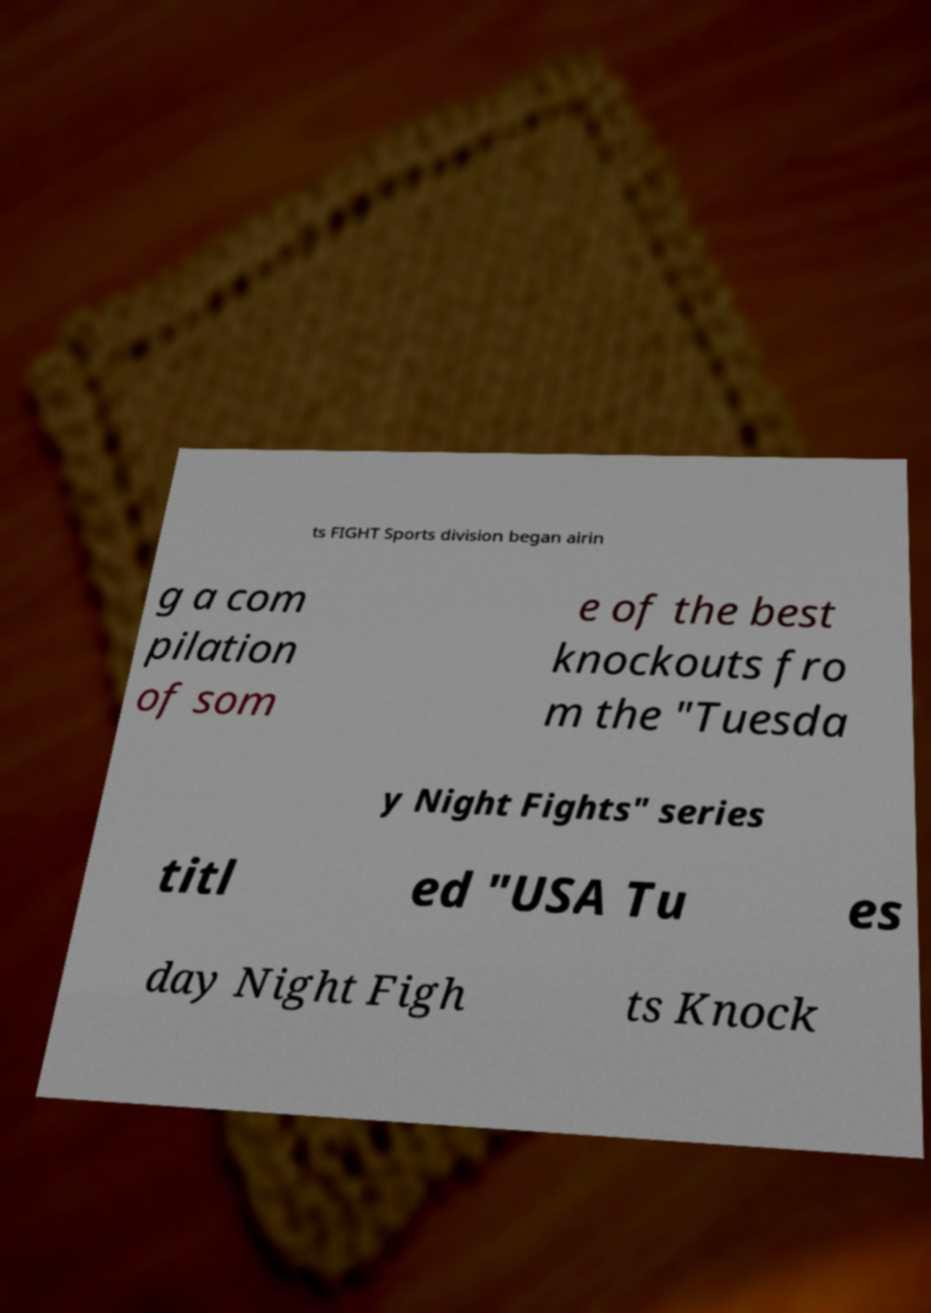Please identify and transcribe the text found in this image. ts FIGHT Sports division began airin g a com pilation of som e of the best knockouts fro m the "Tuesda y Night Fights" series titl ed "USA Tu es day Night Figh ts Knock 